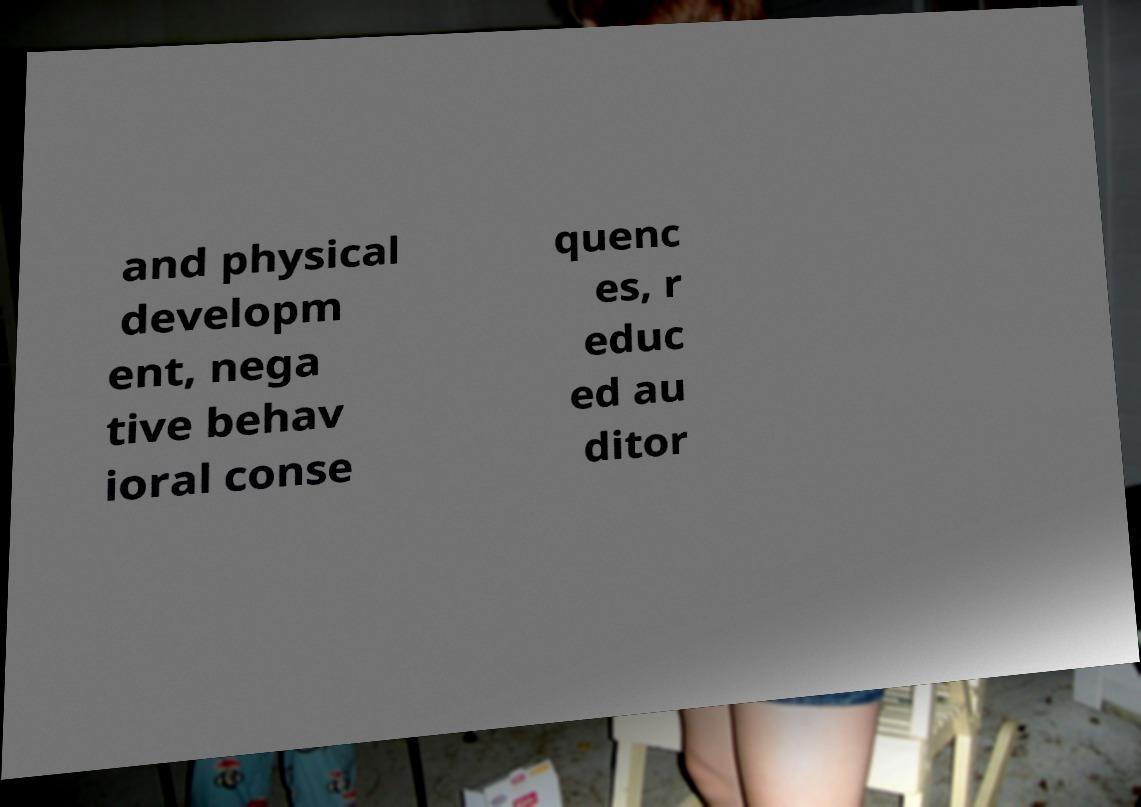There's text embedded in this image that I need extracted. Can you transcribe it verbatim? and physical developm ent, nega tive behav ioral conse quenc es, r educ ed au ditor 